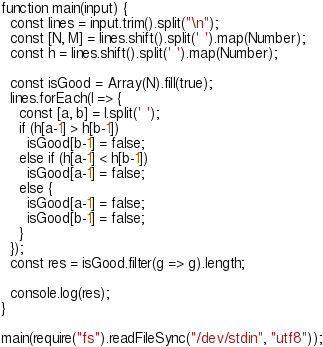<code> <loc_0><loc_0><loc_500><loc_500><_JavaScript_>function main(input) {
  const lines = input.trim().split("\n");
  const [N, M] = lines.shift().split(' ').map(Number);
  const h = lines.shift().split(' ').map(Number);

  const isGood = Array(N).fill(true);
  lines.forEach(l => {
    const [a, b] = l.split(' ');
    if (h[a-1] > h[b-1])
      isGood[b-1] = false;
    else if (h[a-1] < h[b-1])
      isGood[a-1] = false;
    else {
      isGood[a-1] = false;
      isGood[b-1] = false;
    }
  });
  const res = isGood.filter(g => g).length;
  
  console.log(res);
}

main(require("fs").readFileSync("/dev/stdin", "utf8"));</code> 